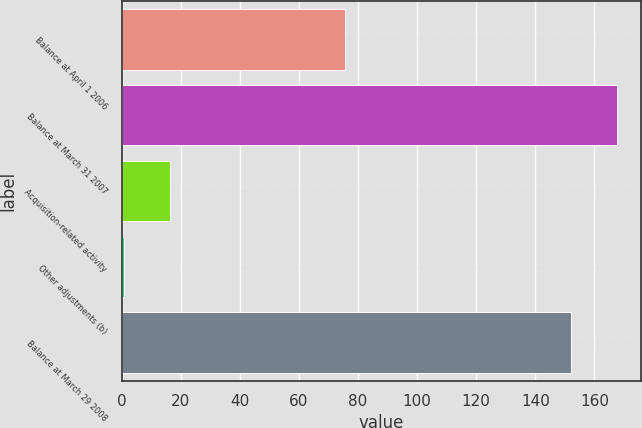Convert chart to OTSL. <chart><loc_0><loc_0><loc_500><loc_500><bar_chart><fcel>Balance at April 1 2006<fcel>Balance at March 31 2007<fcel>Acquisition-related activity<fcel>Other adjustments (b)<fcel>Balance at March 29 2008<nl><fcel>75.4<fcel>167.52<fcel>16.32<fcel>0.9<fcel>152.1<nl></chart> 